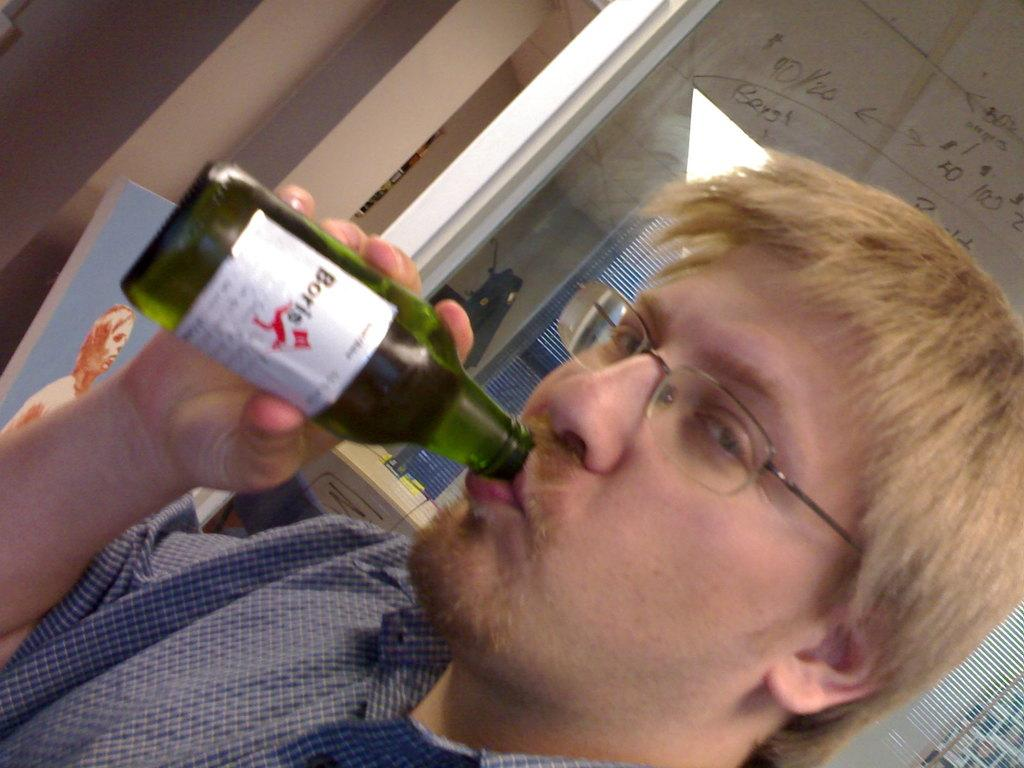What is the man in the image doing? The man is drinking in the image. How is the man positioned in the image? The man is standing in the image. What accessory is the man wearing? The man is wearing glasses in the image. What object is the man using to drink? There is a glass in the image that the man is using. What is written on the glass? There is text written on the glass in the image. What can be seen in the left corner of the image? There is a photo in the left corner of the image. What type of attraction can be seen in the image? There is no attraction present in the image; it features a man drinking from a glass with text on it and a photo in the left corner. Can you tell me how many pigs are visible in the image? There are no pigs present in the image. 